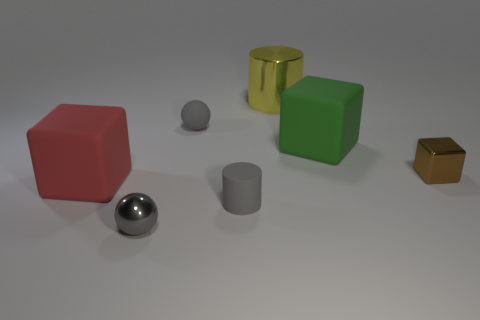There is a gray ball in front of the large cube that is to the right of the cylinder that is in front of the big red matte object; what is its size?
Make the answer very short. Small. Do the red rubber object and the gray matte cylinder have the same size?
Ensure brevity in your answer.  No. There is a gray sphere that is in front of the matte cube that is on the right side of the red block; what is it made of?
Keep it short and to the point. Metal. Does the shiny object to the left of the metallic cylinder have the same shape as the tiny gray rubber thing behind the gray rubber cylinder?
Your answer should be very brief. Yes. Are there an equal number of small shiny things to the left of the matte sphere and small green cubes?
Your response must be concise. No. Are there any gray balls that are behind the cylinder to the left of the yellow shiny cylinder?
Your answer should be very brief. Yes. Are there any other things that are the same color as the small cylinder?
Provide a succinct answer. Yes. Is the material of the big block that is to the right of the yellow metallic thing the same as the small brown block?
Your response must be concise. No. Are there the same number of objects that are right of the gray rubber cylinder and red rubber things behind the big yellow cylinder?
Ensure brevity in your answer.  No. There is a gray sphere that is in front of the large block on the left side of the big yellow thing; what size is it?
Ensure brevity in your answer.  Small. 